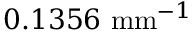Convert formula to latex. <formula><loc_0><loc_0><loc_500><loc_500>0 . 1 3 5 6 \ m m ^ { - 1 }</formula> 